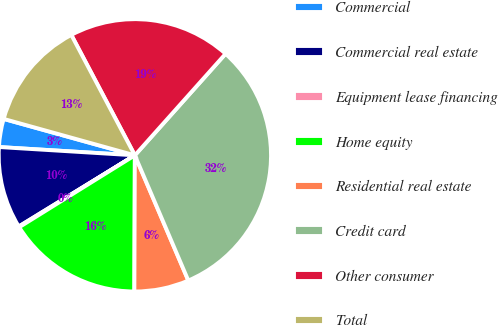Convert chart. <chart><loc_0><loc_0><loc_500><loc_500><pie_chart><fcel>Commercial<fcel>Commercial real estate<fcel>Equipment lease financing<fcel>Home equity<fcel>Residential real estate<fcel>Credit card<fcel>Other consumer<fcel>Total<nl><fcel>3.34%<fcel>9.72%<fcel>0.1%<fcel>16.09%<fcel>6.48%<fcel>31.97%<fcel>19.33%<fcel>12.96%<nl></chart> 